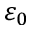<formula> <loc_0><loc_0><loc_500><loc_500>\varepsilon _ { 0 }</formula> 